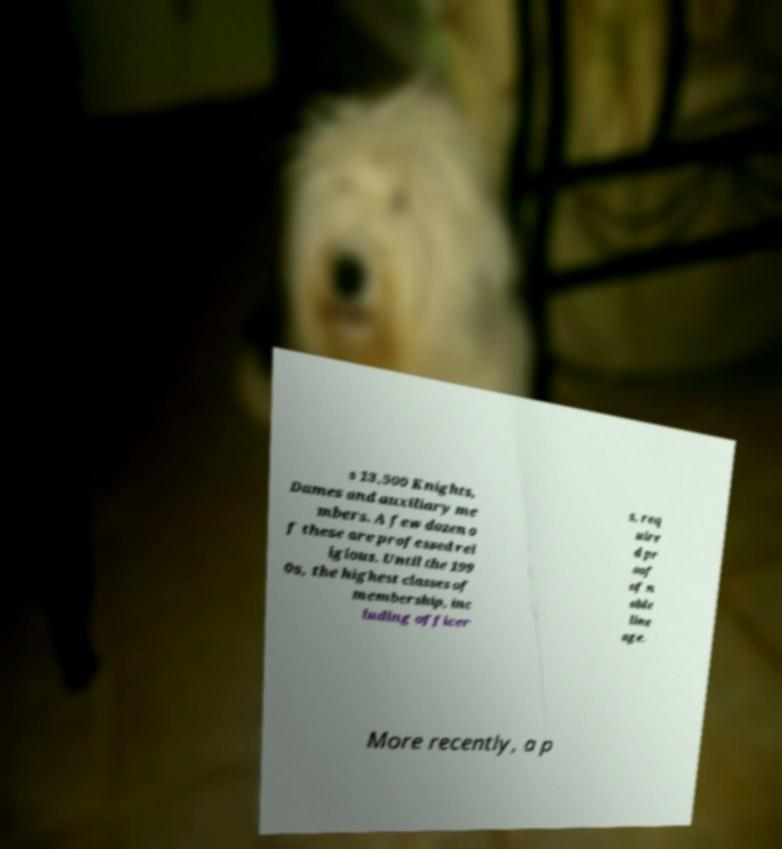Could you assist in decoding the text presented in this image and type it out clearly? s 13,500 Knights, Dames and auxiliary me mbers. A few dozen o f these are professed rel igious. Until the 199 0s, the highest classes of membership, inc luding officer s, req uire d pr oof of n oble line age. More recently, a p 